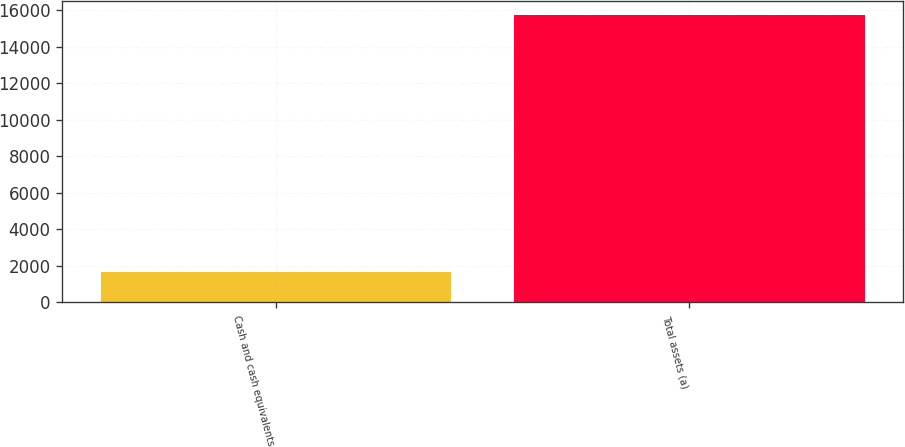Convert chart. <chart><loc_0><loc_0><loc_500><loc_500><bar_chart><fcel>Cash and cash equivalents<fcel>Total assets (a)<nl><fcel>1643<fcel>15711<nl></chart> 